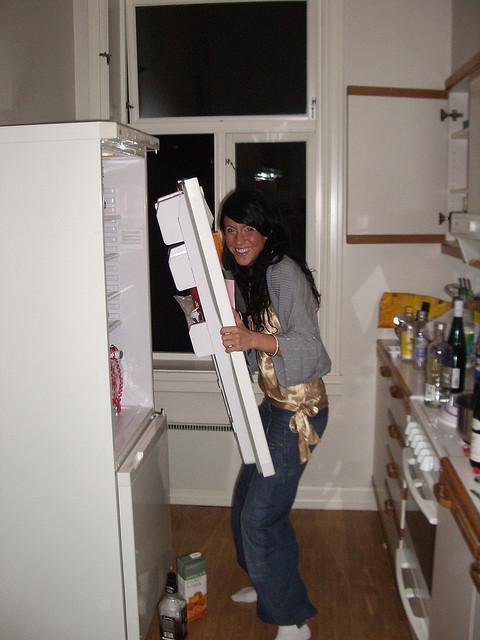How many ovens can you see?
Give a very brief answer. 1. How many bikes are shown?
Give a very brief answer. 0. 